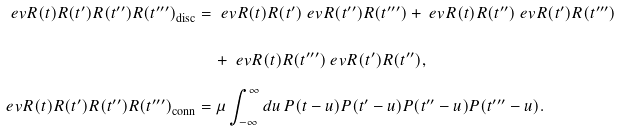Convert formula to latex. <formula><loc_0><loc_0><loc_500><loc_500>\ e v { R ( t ) R ( t ^ { \prime } ) R ( t ^ { \prime \prime } ) R ( t ^ { \prime \prime \prime } ) } _ { \text {disc} } & = \ e v { R ( t ) R ( t ^ { \prime } ) } \ e v { R ( t ^ { \prime \prime } ) R ( t ^ { \prime \prime \prime } ) } + \ e v { R ( t ) R ( t ^ { \prime \prime } ) } \ e v { R ( t ^ { \prime } ) R ( t ^ { \prime \prime \prime } ) } \\ & \quad + \ e v { R ( t ) R ( t ^ { \prime \prime \prime } ) } \ e v { R ( t ^ { \prime } ) R ( t ^ { \prime \prime } ) } , \\ \ e v { R ( t ) R ( t ^ { \prime } ) R ( t ^ { \prime \prime } ) R ( t ^ { \prime \prime \prime } ) } _ { \text {conn} } & = \mu \int _ { - \infty } ^ { \infty } d u \, P ( t - u ) P ( t ^ { \prime } - u ) P ( t ^ { \prime \prime } - u ) P ( t ^ { \prime \prime \prime } - u ) .</formula> 